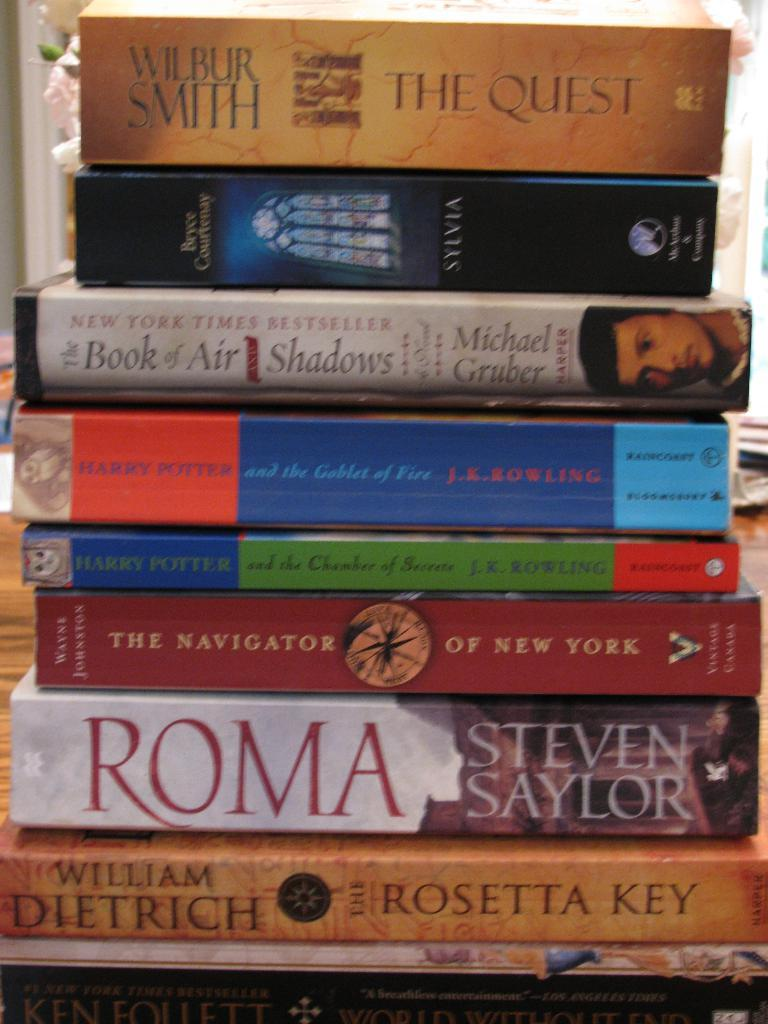<image>
Offer a succinct explanation of the picture presented. a stack of books with one called 'roma' by steven saylor 